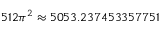Convert formula to latex. <formula><loc_0><loc_0><loc_500><loc_500>5 1 2 \pi ^ { 2 } \approx 5 0 5 3 . 2 3 7 4 5 3 3 5 7 7 5 1</formula> 